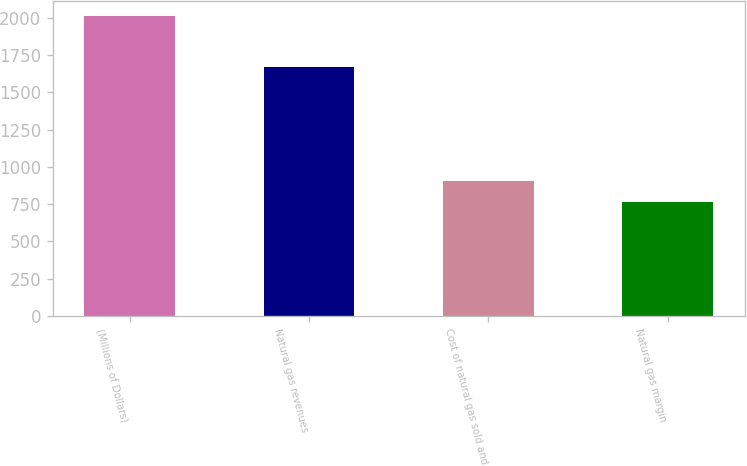Convert chart. <chart><loc_0><loc_0><loc_500><loc_500><bar_chart><fcel>(Millions of Dollars)<fcel>Natural gas revenues<fcel>Cost of natural gas sold and<fcel>Natural gas margin<nl><fcel>2015<fcel>1672<fcel>905<fcel>767<nl></chart> 